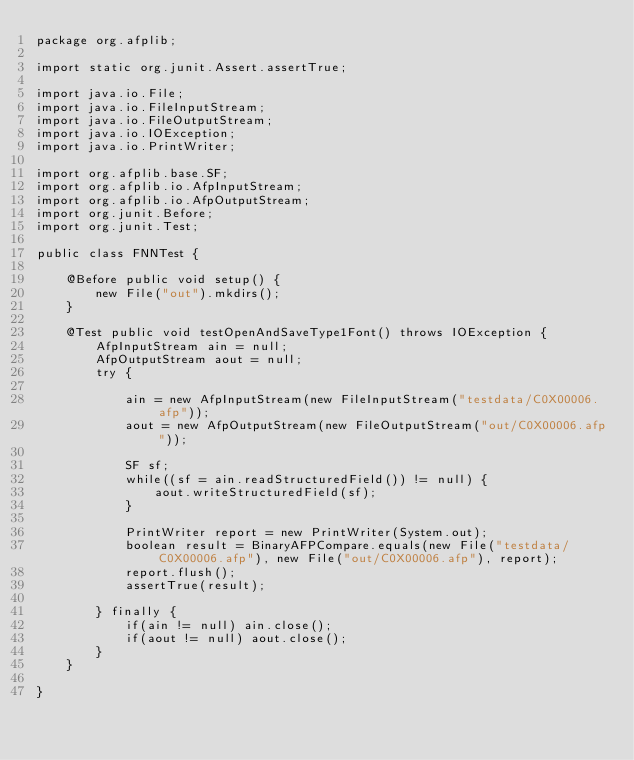<code> <loc_0><loc_0><loc_500><loc_500><_Java_>package org.afplib;

import static org.junit.Assert.assertTrue;

import java.io.File;
import java.io.FileInputStream;
import java.io.FileOutputStream;
import java.io.IOException;
import java.io.PrintWriter;

import org.afplib.base.SF;
import org.afplib.io.AfpInputStream;
import org.afplib.io.AfpOutputStream;
import org.junit.Before;
import org.junit.Test;

public class FNNTest {

	@Before public void setup() {
		new File("out").mkdirs();
	}

	@Test public void testOpenAndSaveType1Font() throws IOException {
		AfpInputStream ain = null;
		AfpOutputStream aout = null;
		try {

			ain = new AfpInputStream(new FileInputStream("testdata/C0X00006.afp"));
			aout = new AfpOutputStream(new FileOutputStream("out/C0X00006.afp"));

			SF sf;
			while((sf = ain.readStructuredField()) != null) {
				aout.writeStructuredField(sf);
			}

			PrintWriter report = new PrintWriter(System.out);
			boolean result = BinaryAFPCompare.equals(new File("testdata/C0X00006.afp"), new File("out/C0X00006.afp"), report);
			report.flush();
			assertTrue(result);

		} finally {
			if(ain != null) ain.close();
			if(aout != null) aout.close();
		}
	}

}
</code> 